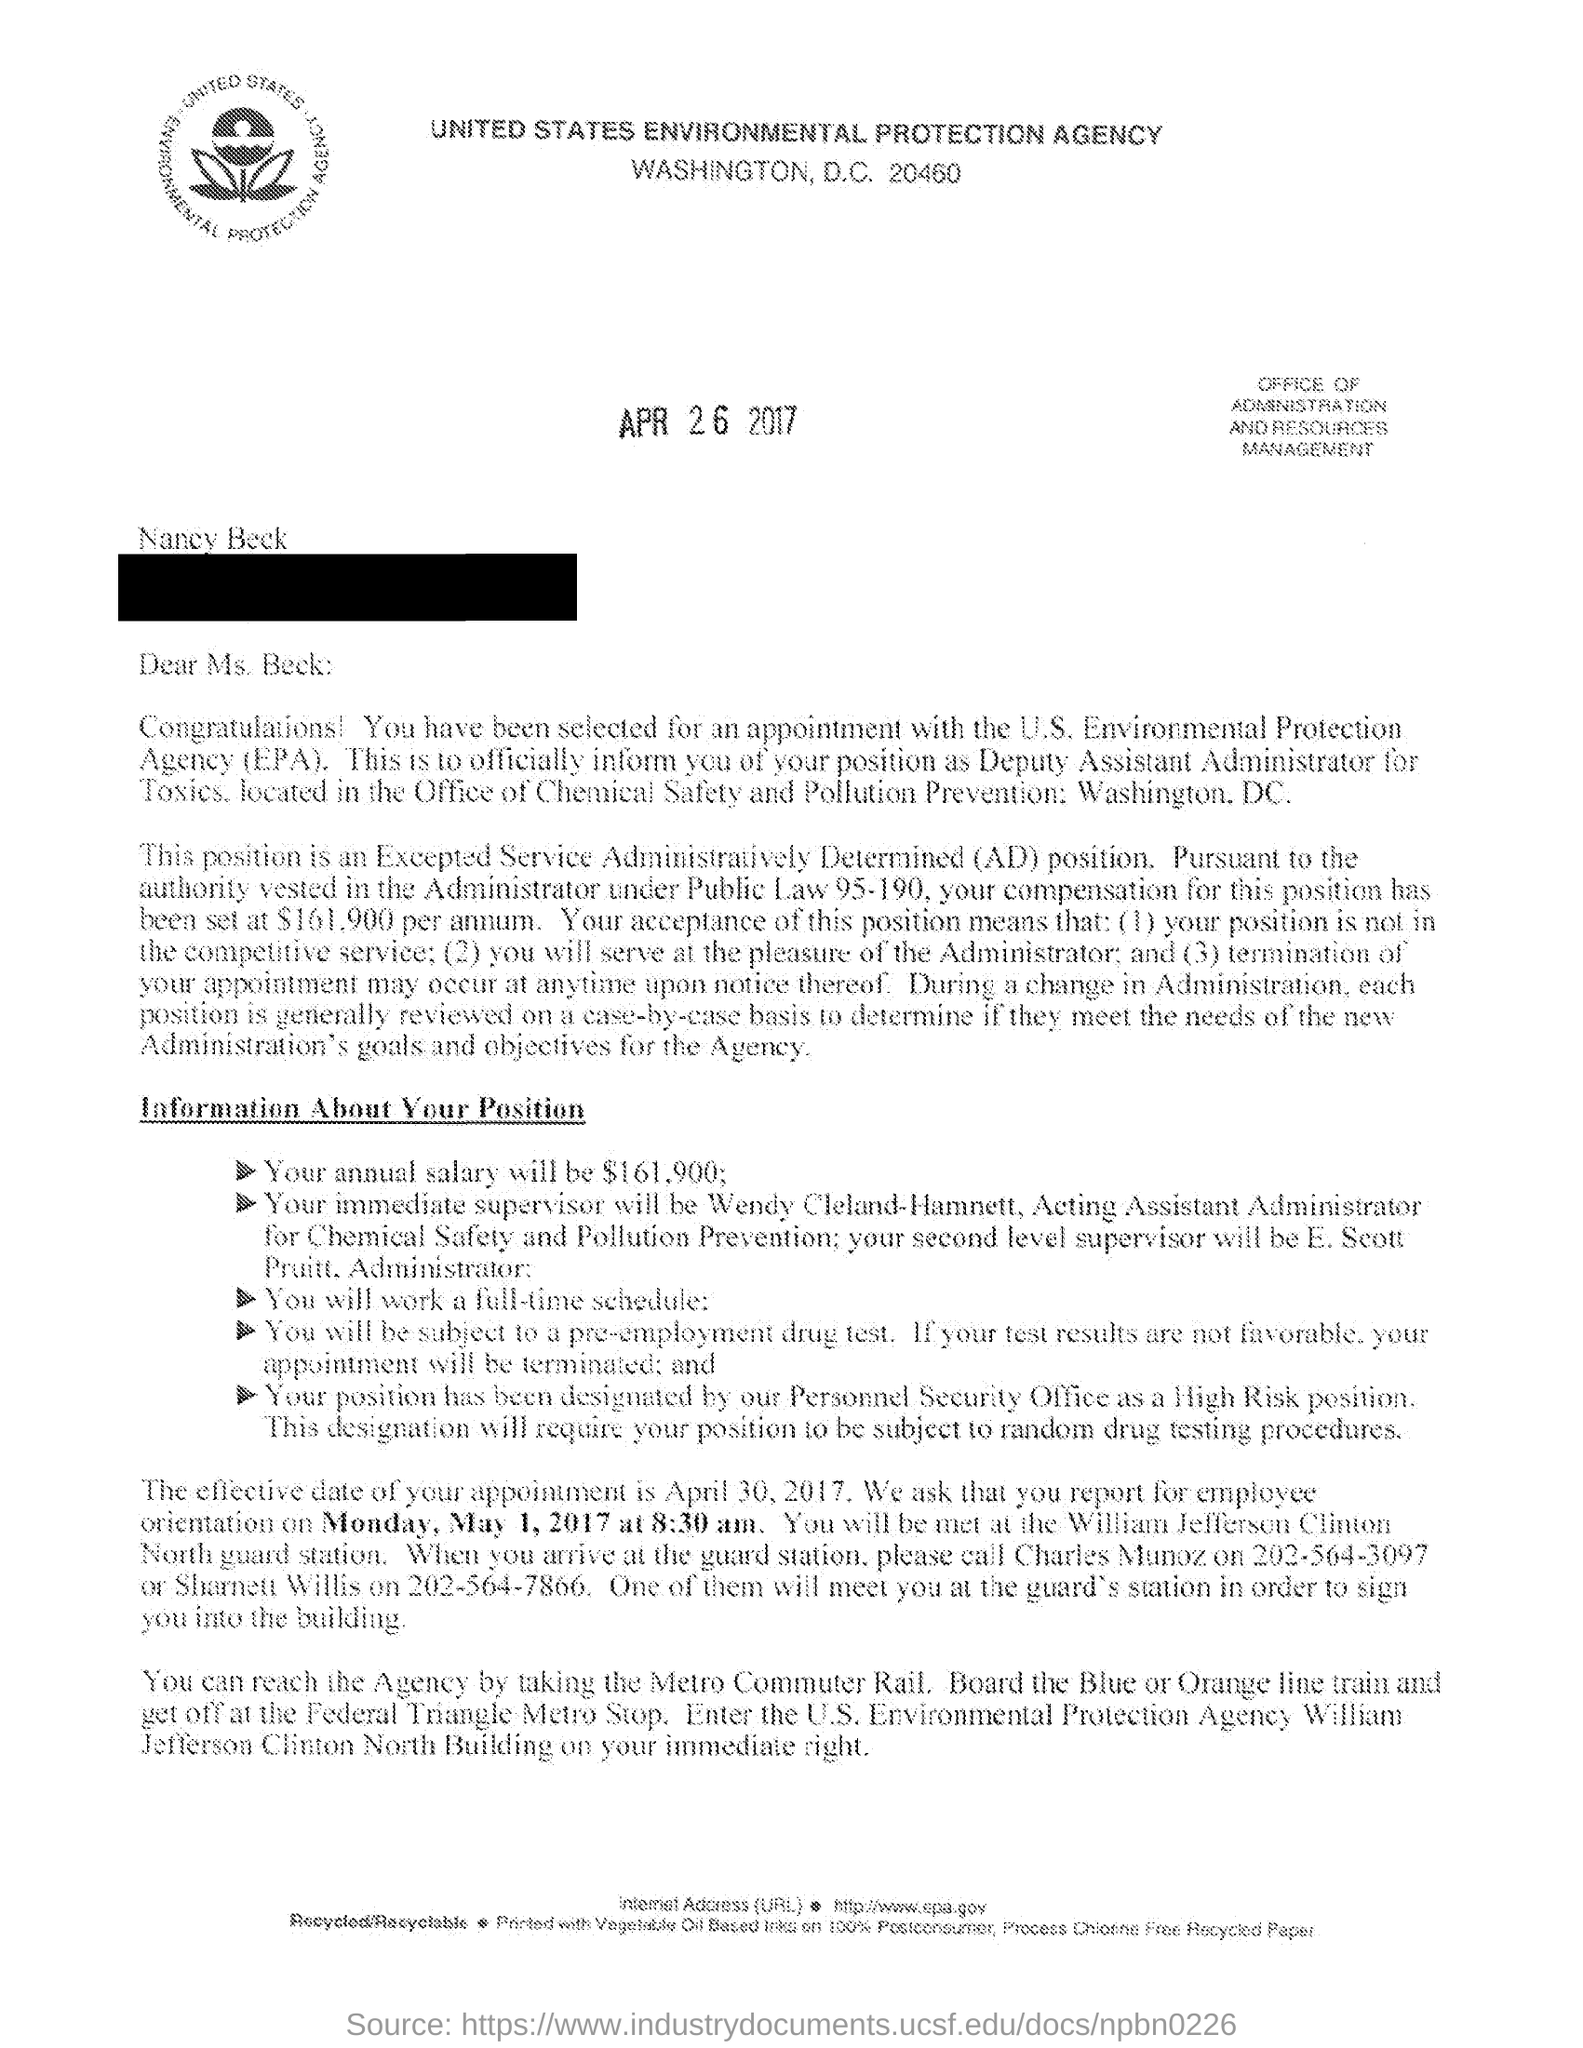Outline some significant characteristics in this image. The orientation is scheduled to start at 8:30 am on Monday, May 1, 2017. The compensation for the AD position at Beck has been set at an annual salary of $161,900, The acronym "EPA" stands for "Environmental Protection Agency," which is a government agency responsible for protecting and preserving the natural environment and human health. Beck's appointment was effective on April 30, 2017. The person who has been selected for an appointment in the letter is named Nancy Beck. 